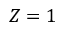<formula> <loc_0><loc_0><loc_500><loc_500>Z = 1</formula> 